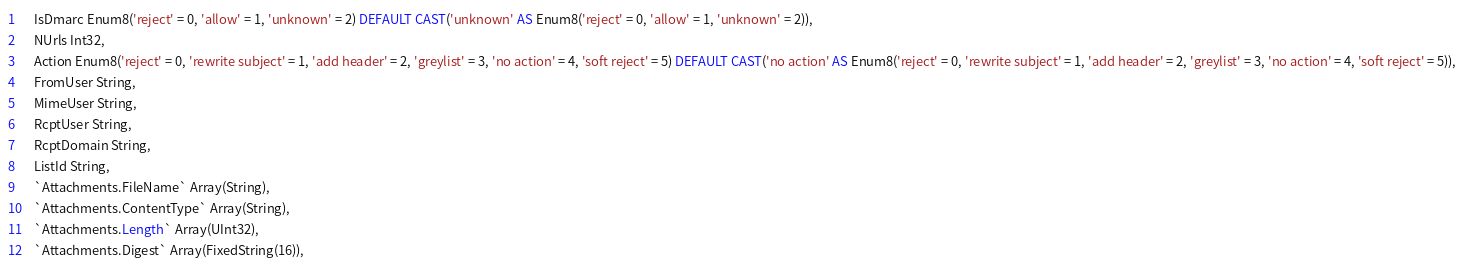<code> <loc_0><loc_0><loc_500><loc_500><_SQL_>    IsDmarc Enum8('reject' = 0, 'allow' = 1, 'unknown' = 2) DEFAULT CAST('unknown' AS Enum8('reject' = 0, 'allow' = 1, 'unknown' = 2)),
    NUrls Int32,
    Action Enum8('reject' = 0, 'rewrite subject' = 1, 'add header' = 2, 'greylist' = 3, 'no action' = 4, 'soft reject' = 5) DEFAULT CAST('no action' AS Enum8('reject' = 0, 'rewrite subject' = 1, 'add header' = 2, 'greylist' = 3, 'no action' = 4, 'soft reject' = 5)),
    FromUser String,
    MimeUser String,
    RcptUser String,
    RcptDomain String,
    ListId String,
    `Attachments.FileName` Array(String),
    `Attachments.ContentType` Array(String),
    `Attachments.Length` Array(UInt32),
    `Attachments.Digest` Array(FixedString(16)),</code> 